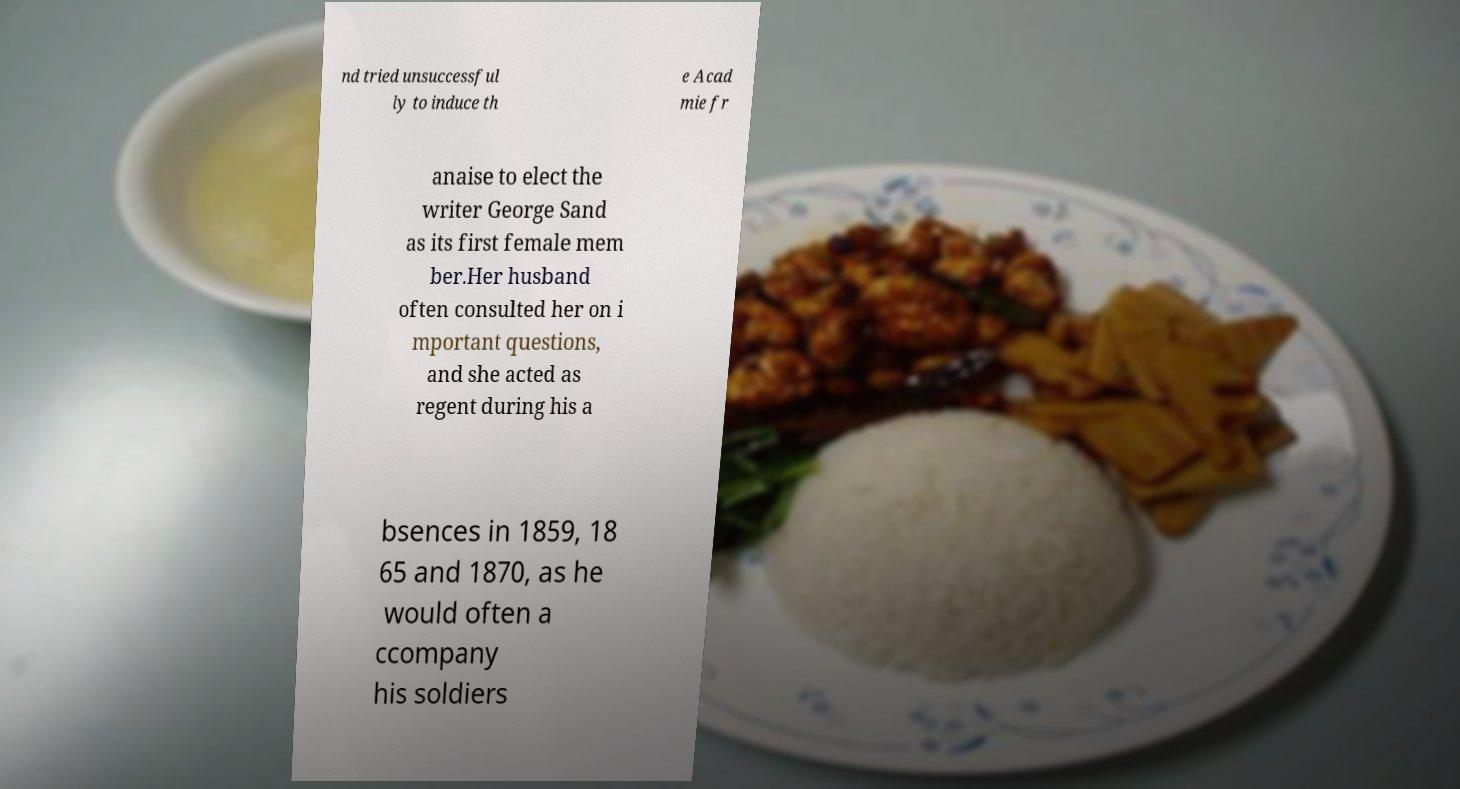Can you read and provide the text displayed in the image?This photo seems to have some interesting text. Can you extract and type it out for me? nd tried unsuccessful ly to induce th e Acad mie fr anaise to elect the writer George Sand as its first female mem ber.Her husband often consulted her on i mportant questions, and she acted as regent during his a bsences in 1859, 18 65 and 1870, as he would often a ccompany his soldiers 